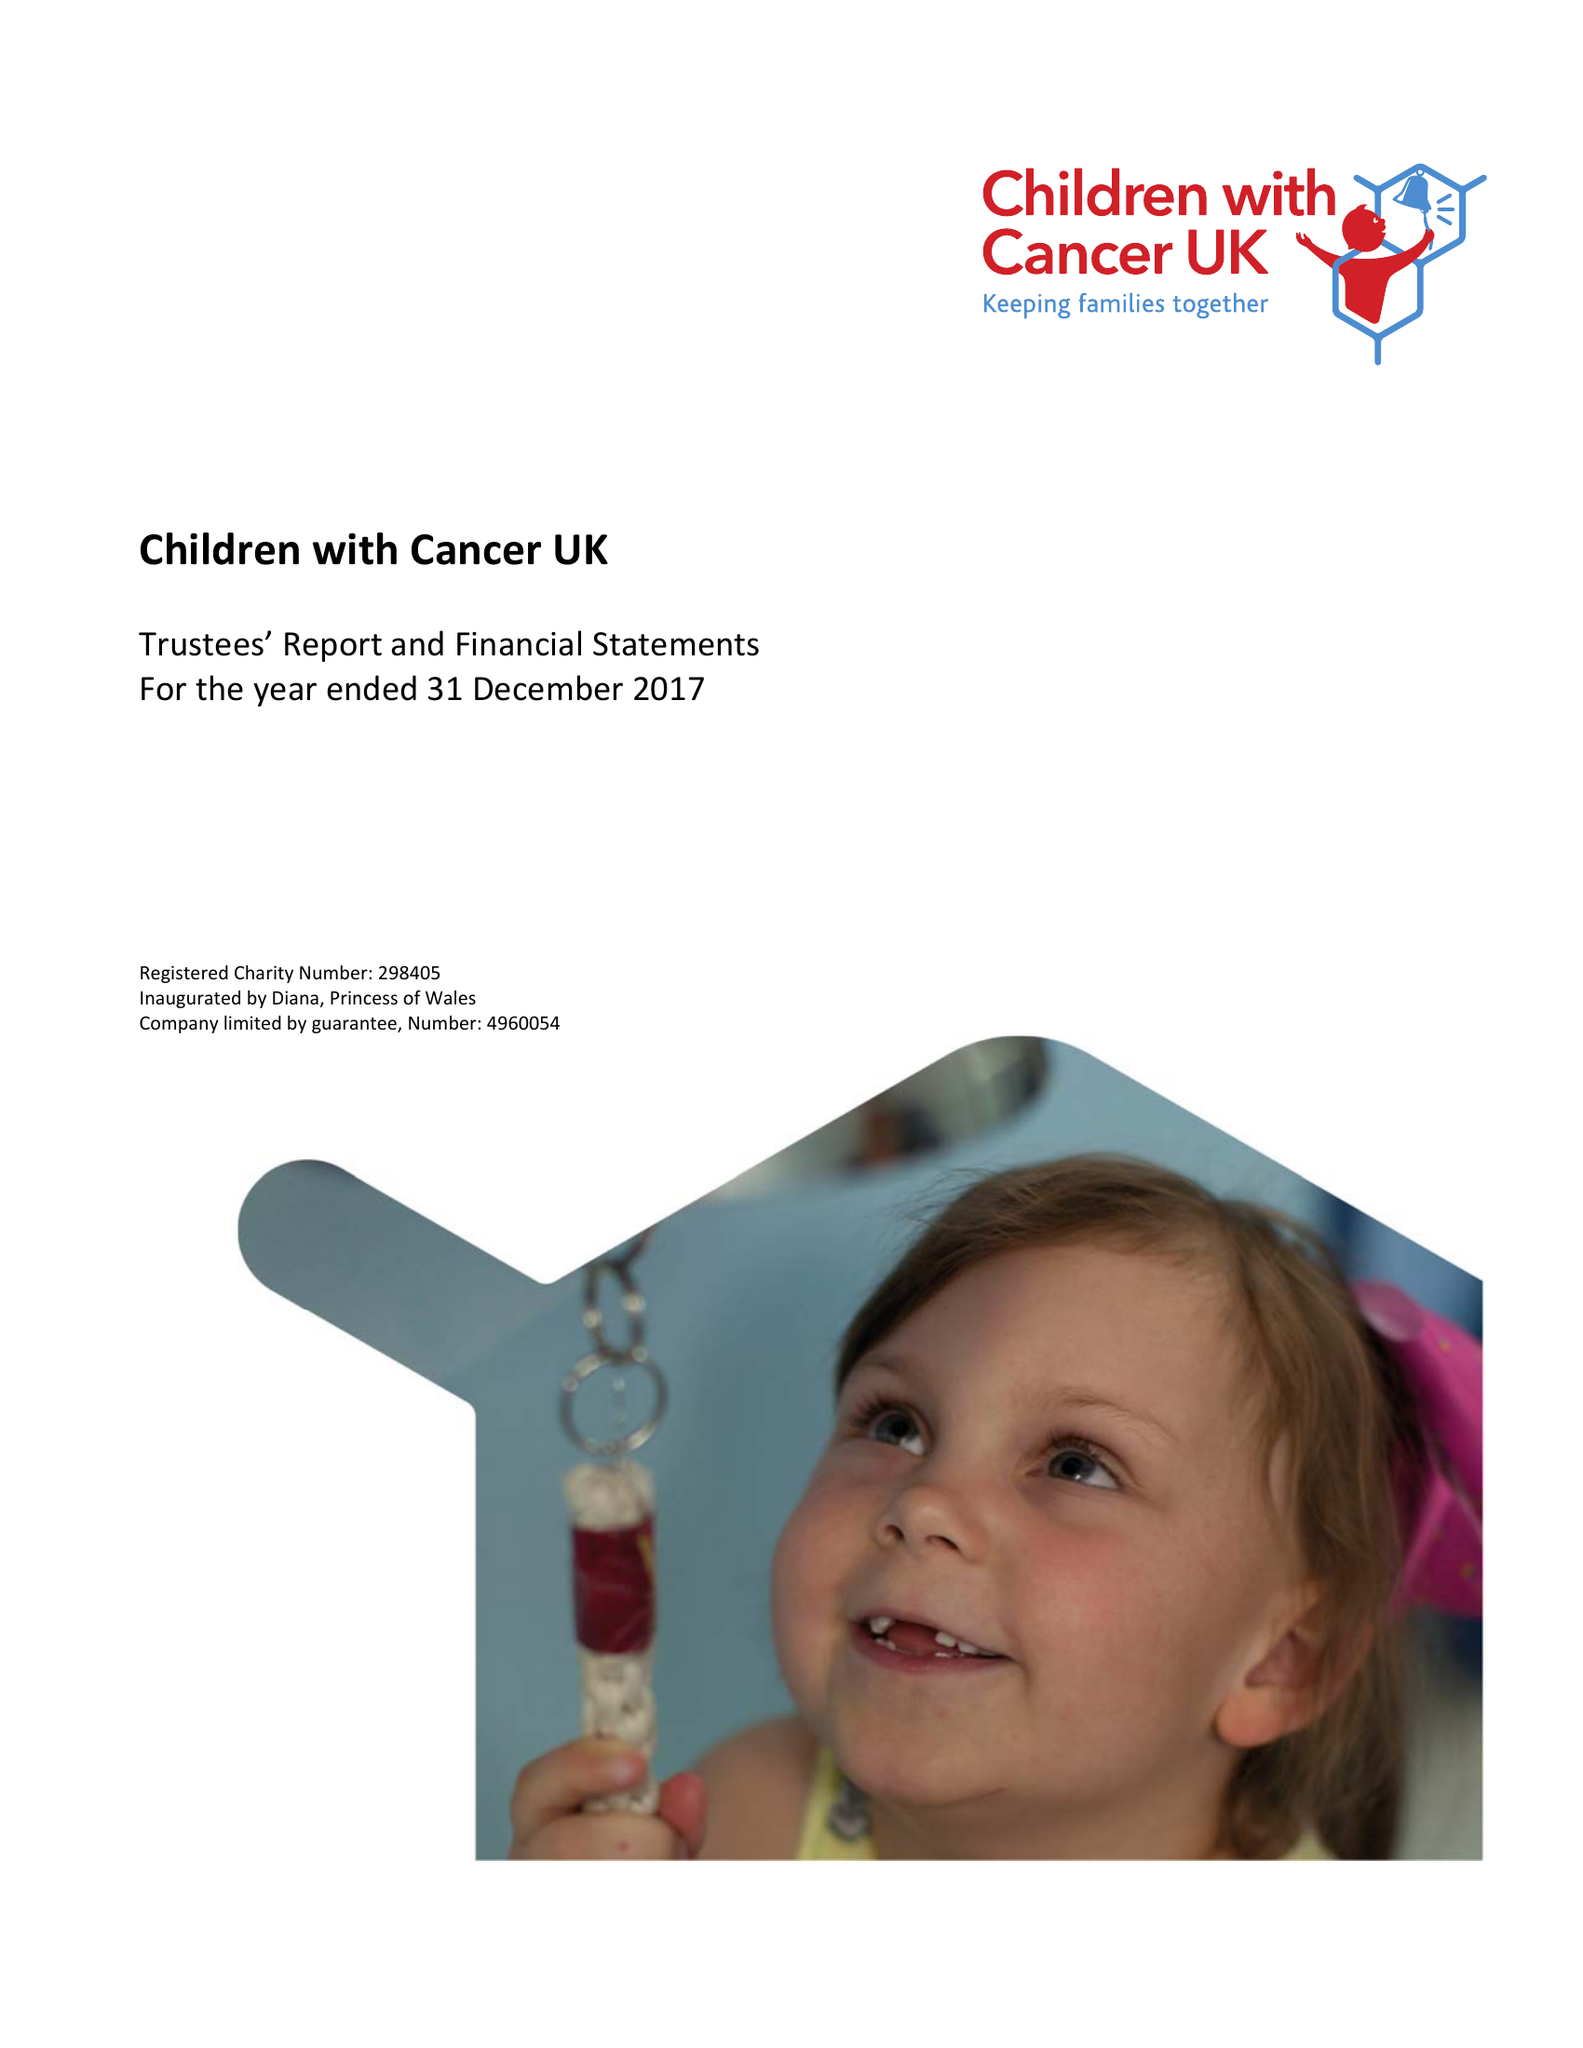What is the value for the charity_number?
Answer the question using a single word or phrase. 298405 